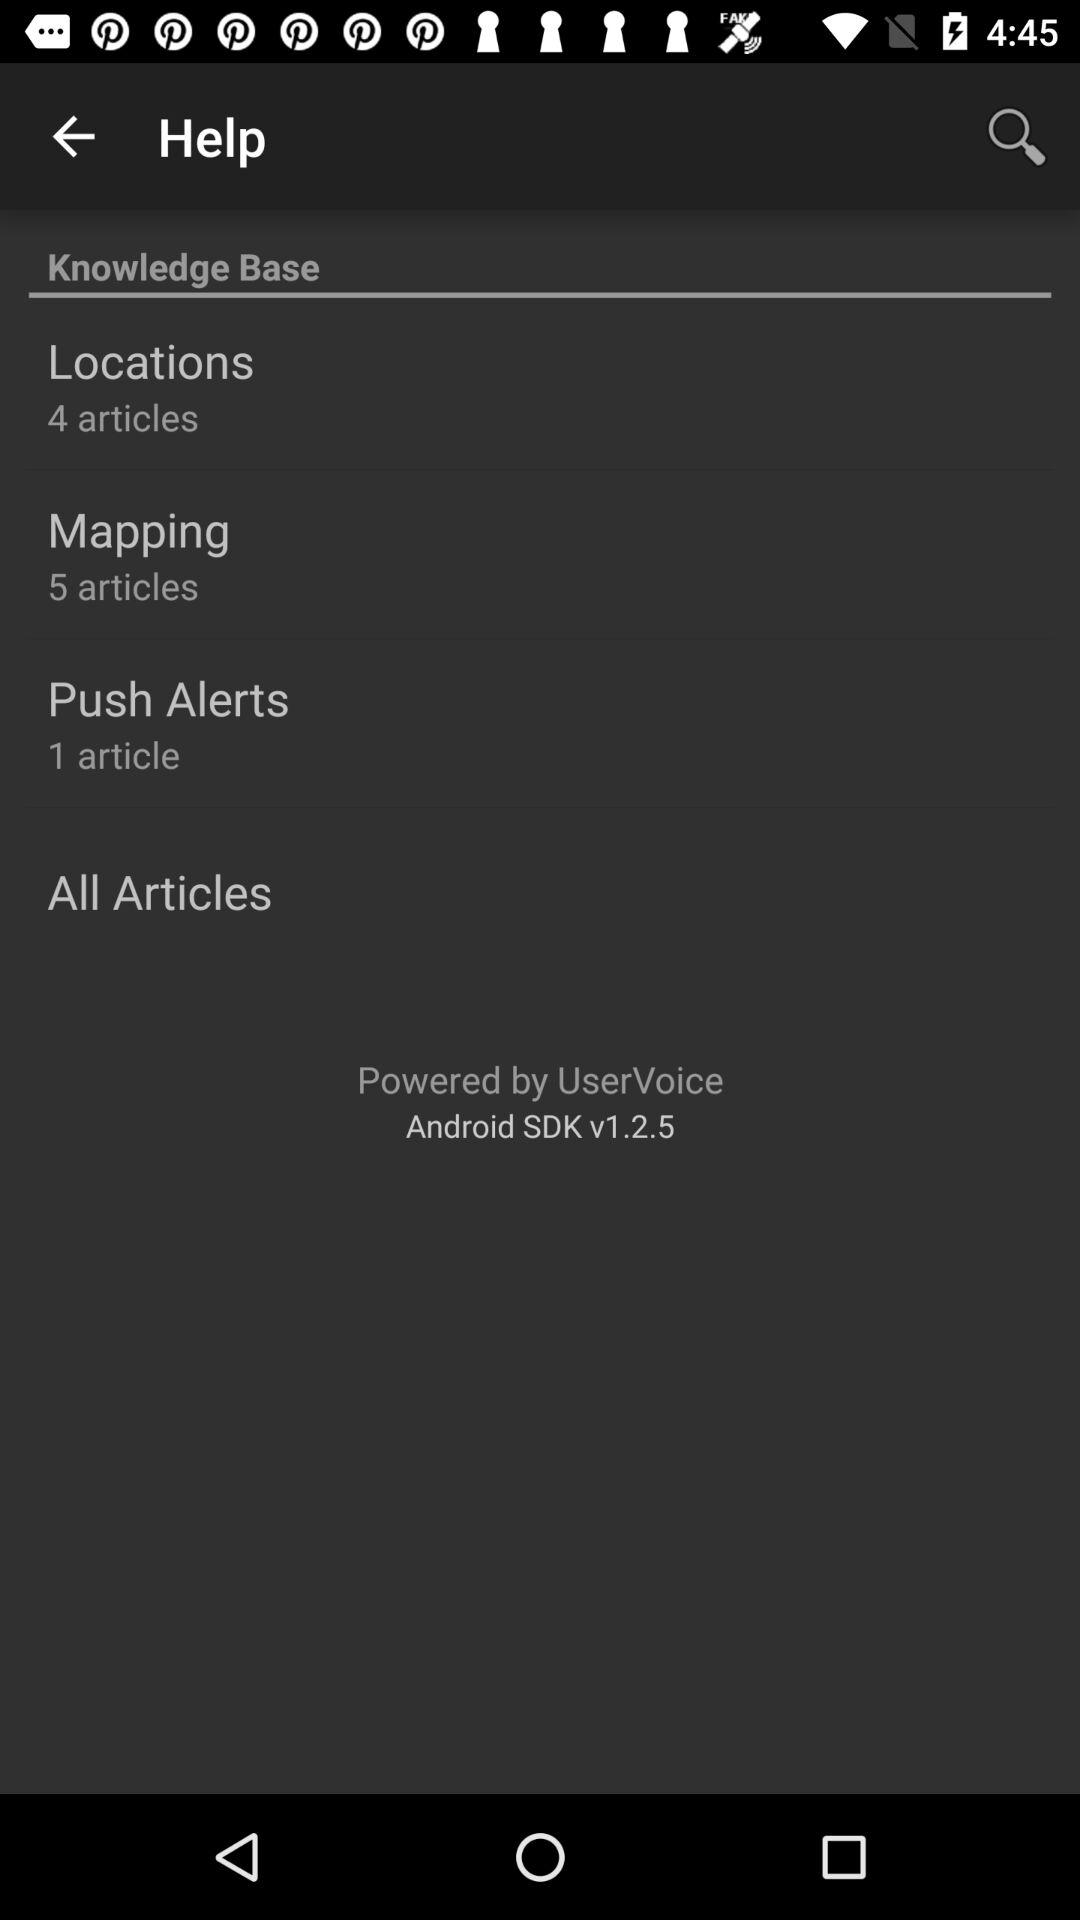How many articles belong to the locations? The number of articles is 4. 